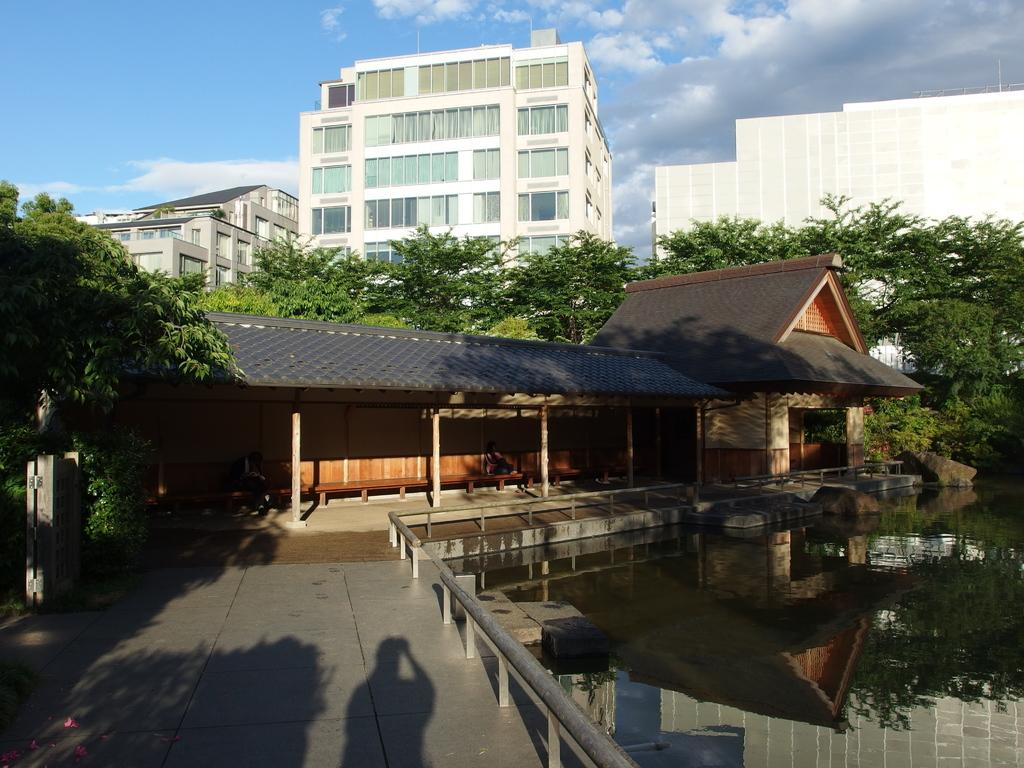What can be seen on the right side of the image? There is water visible on the right side of the image. What is visible in the background of the image? There are trees, buildings, and clouds in the sky in the background of the image. What type of dolls can be seen reading a book in the image? There are no dolls or books present in the image. What nation is depicted in the image? The image does not depict any specific nation. 